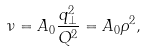Convert formula to latex. <formula><loc_0><loc_0><loc_500><loc_500>\nu = A _ { 0 } \frac { { q } _ { \perp } ^ { 2 } } { Q ^ { 2 } } = A _ { 0 } \rho ^ { 2 } ,</formula> 